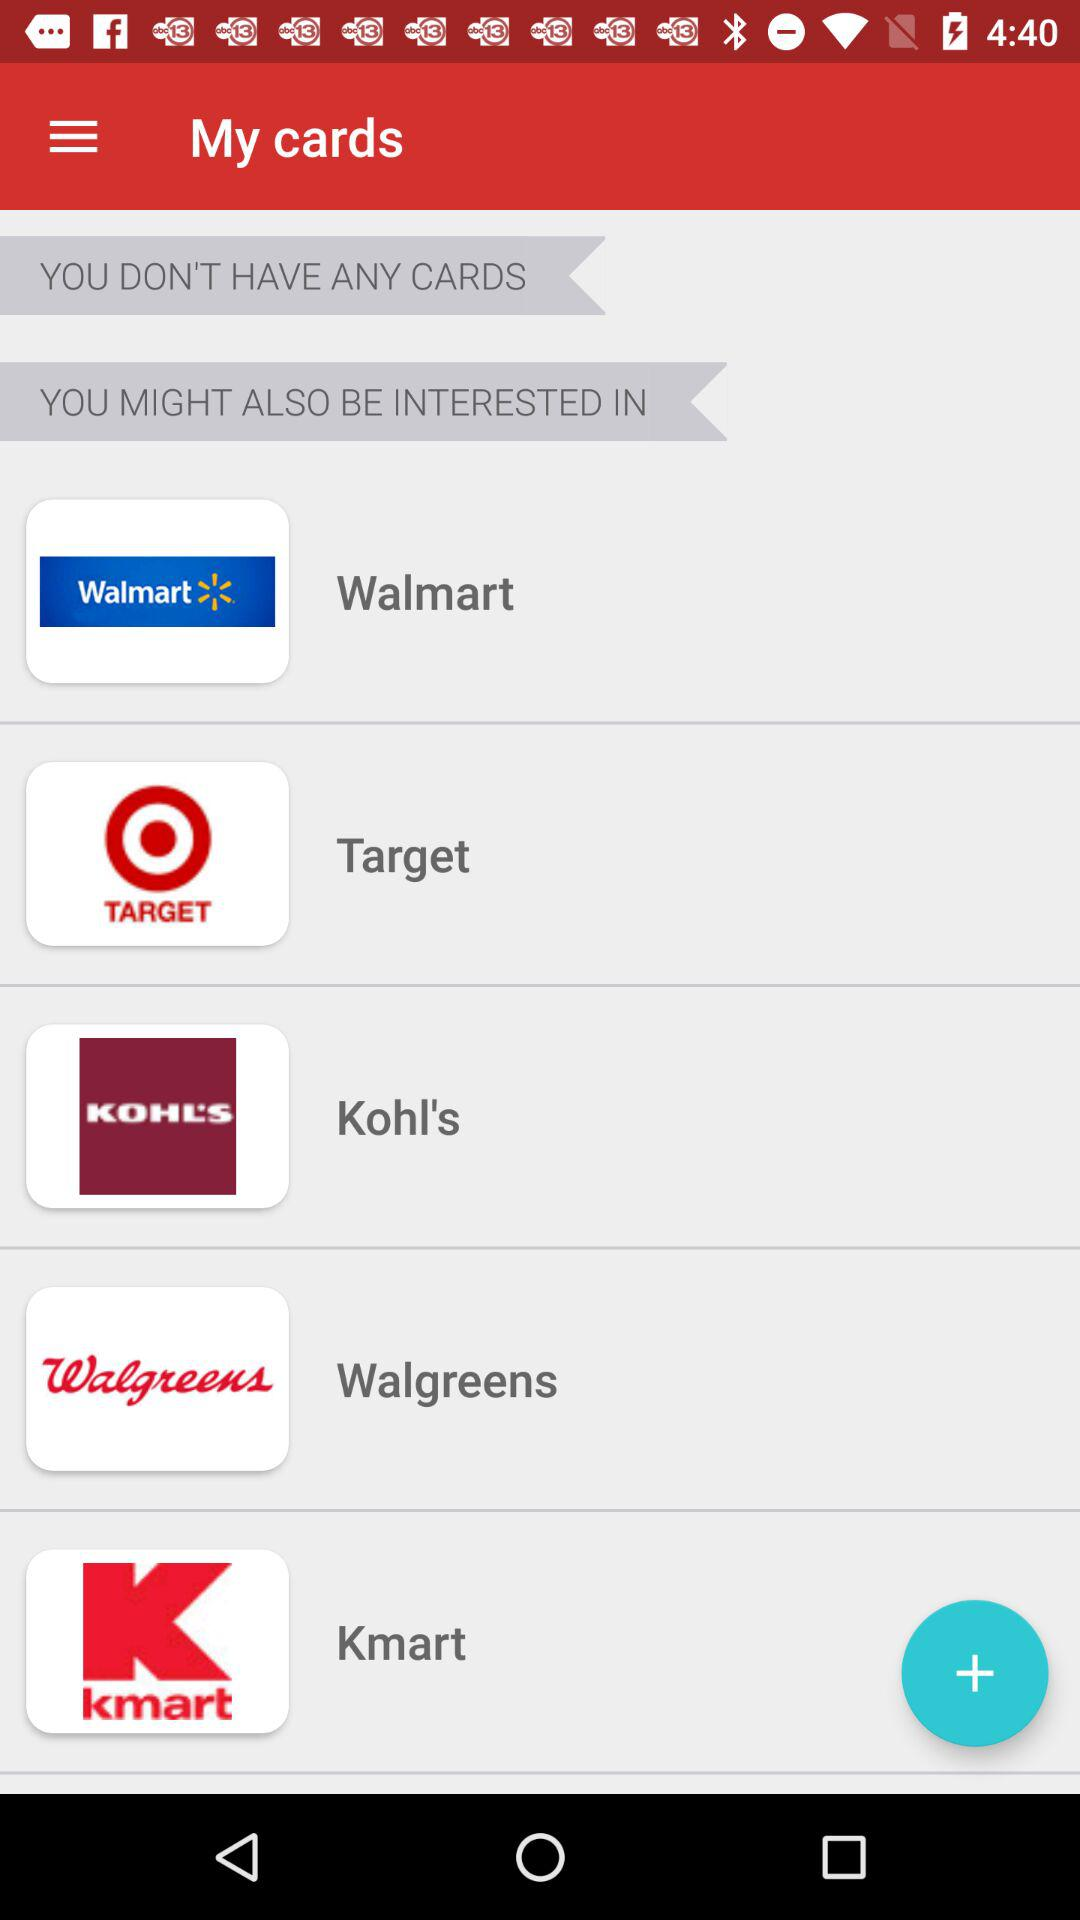Are there any cards? You don't have any cards. 